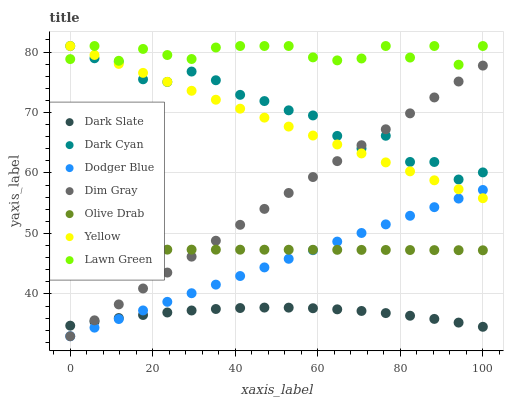Does Dark Slate have the minimum area under the curve?
Answer yes or no. Yes. Does Lawn Green have the maximum area under the curve?
Answer yes or no. Yes. Does Dim Gray have the minimum area under the curve?
Answer yes or no. No. Does Dim Gray have the maximum area under the curve?
Answer yes or no. No. Is Dodger Blue the smoothest?
Answer yes or no. Yes. Is Lawn Green the roughest?
Answer yes or no. Yes. Is Dim Gray the smoothest?
Answer yes or no. No. Is Dim Gray the roughest?
Answer yes or no. No. Does Dim Gray have the lowest value?
Answer yes or no. Yes. Does Yellow have the lowest value?
Answer yes or no. No. Does Dark Cyan have the highest value?
Answer yes or no. Yes. Does Dim Gray have the highest value?
Answer yes or no. No. Is Dark Slate less than Dark Cyan?
Answer yes or no. Yes. Is Lawn Green greater than Olive Drab?
Answer yes or no. Yes. Does Dark Cyan intersect Lawn Green?
Answer yes or no. Yes. Is Dark Cyan less than Lawn Green?
Answer yes or no. No. Is Dark Cyan greater than Lawn Green?
Answer yes or no. No. Does Dark Slate intersect Dark Cyan?
Answer yes or no. No. 